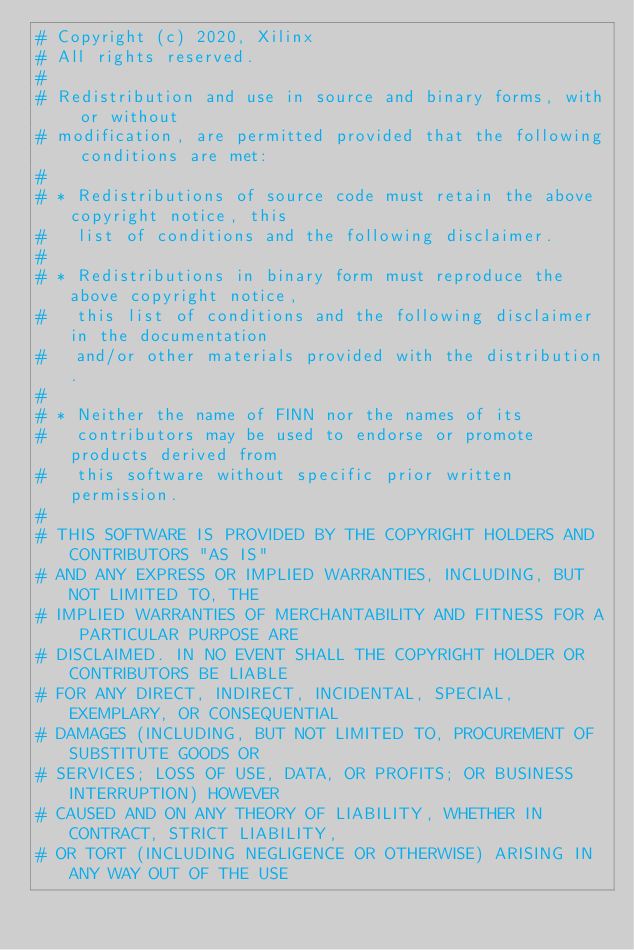<code> <loc_0><loc_0><loc_500><loc_500><_Python_># Copyright (c) 2020, Xilinx
# All rights reserved.
#
# Redistribution and use in source and binary forms, with or without
# modification, are permitted provided that the following conditions are met:
#
# * Redistributions of source code must retain the above copyright notice, this
#   list of conditions and the following disclaimer.
#
# * Redistributions in binary form must reproduce the above copyright notice,
#   this list of conditions and the following disclaimer in the documentation
#   and/or other materials provided with the distribution.
#
# * Neither the name of FINN nor the names of its
#   contributors may be used to endorse or promote products derived from
#   this software without specific prior written permission.
#
# THIS SOFTWARE IS PROVIDED BY THE COPYRIGHT HOLDERS AND CONTRIBUTORS "AS IS"
# AND ANY EXPRESS OR IMPLIED WARRANTIES, INCLUDING, BUT NOT LIMITED TO, THE
# IMPLIED WARRANTIES OF MERCHANTABILITY AND FITNESS FOR A PARTICULAR PURPOSE ARE
# DISCLAIMED. IN NO EVENT SHALL THE COPYRIGHT HOLDER OR CONTRIBUTORS BE LIABLE
# FOR ANY DIRECT, INDIRECT, INCIDENTAL, SPECIAL, EXEMPLARY, OR CONSEQUENTIAL
# DAMAGES (INCLUDING, BUT NOT LIMITED TO, PROCUREMENT OF SUBSTITUTE GOODS OR
# SERVICES; LOSS OF USE, DATA, OR PROFITS; OR BUSINESS INTERRUPTION) HOWEVER
# CAUSED AND ON ANY THEORY OF LIABILITY, WHETHER IN CONTRACT, STRICT LIABILITY,
# OR TORT (INCLUDING NEGLIGENCE OR OTHERWISE) ARISING IN ANY WAY OUT OF THE USE</code> 